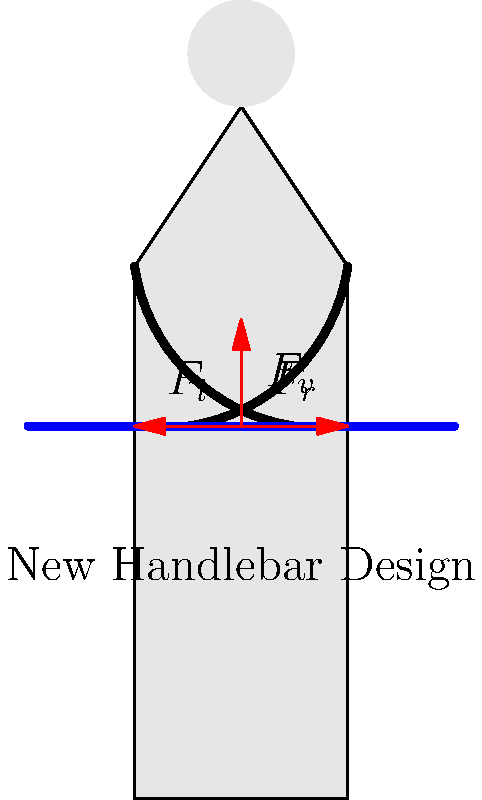Analyze the ergonomics of the new bicycle handlebar design shown in the diagram. Which force vector is likely to cause the most strain on the rider's wrists during long rides, and how might you modify the design to reduce this strain? To analyze the ergonomics of the new bicycle handlebar design, we need to consider the three force vectors shown in the diagram:

1. $F_v$: Vertical force (pointing upwards)
2. $F_l$: Lateral force to the left
3. $F_r$: Lateral force to the right

Step 1: Identify the most problematic force
The vertical force $F_v$ is likely to cause the most strain on the rider's wrists during long rides. This is because:
a) It's constantly working against gravity
b) It puts pressure on the carpal tunnel area of the wrist
c) It can lead to numbness and fatigue over time

Step 2: Analyze the impact of the lateral forces
The lateral forces $F_l$ and $F_r$ are opposing each other, which helps to stabilize the handlebar. However, they may contribute to some wrist strain if the handlebar is too wide.

Step 3: Consider potential modifications
To reduce the strain caused by the vertical force $F_v$, we could:
a) Increase the angle of the handlebar grips to create a more natural wrist position
b) Add ergonomic grips with palm support to distribute pressure more evenly
c) Incorporate shock-absorbing materials to reduce vibration transfer

Step 4: Address the lateral forces
To optimize the lateral forces:
a) Adjust the width of the handlebar to match the rider's shoulder width
b) Use a slight inward curve at the ends to reduce reach

Step 5: Final recommendation
Implement a combination of these modifications:
- Increase the grip angle by 10-15 degrees
- Add ergonomic grips with palm support
- Incorporate shock-absorbing materials
- Optimize handlebar width and add a slight inward curve at the ends

These changes will help reduce wrist strain, especially from the vertical force, while maintaining stability and control.
Answer: Vertical force ($F_v$); increase grip angle, add ergonomic grips with palm support, use shock-absorbing materials, and optimize handlebar width. 